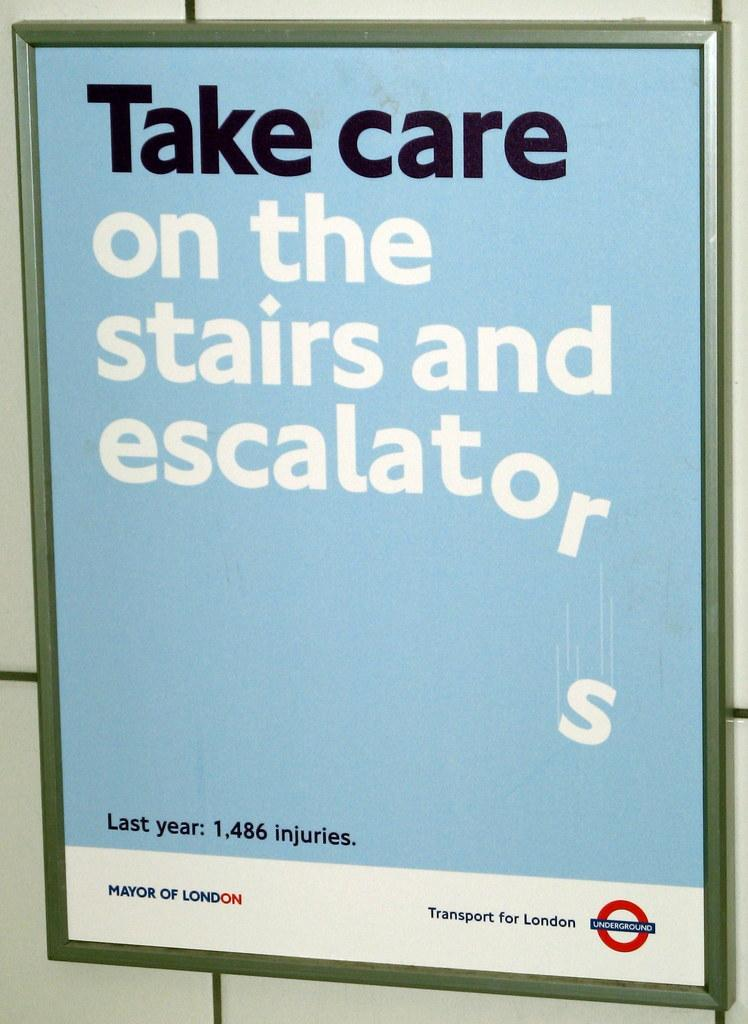<image>
Share a concise interpretation of the image provided. A sign produced by Transport for London saying to be careful on the stairs and escalators because there were 1,486 injuries last year. 